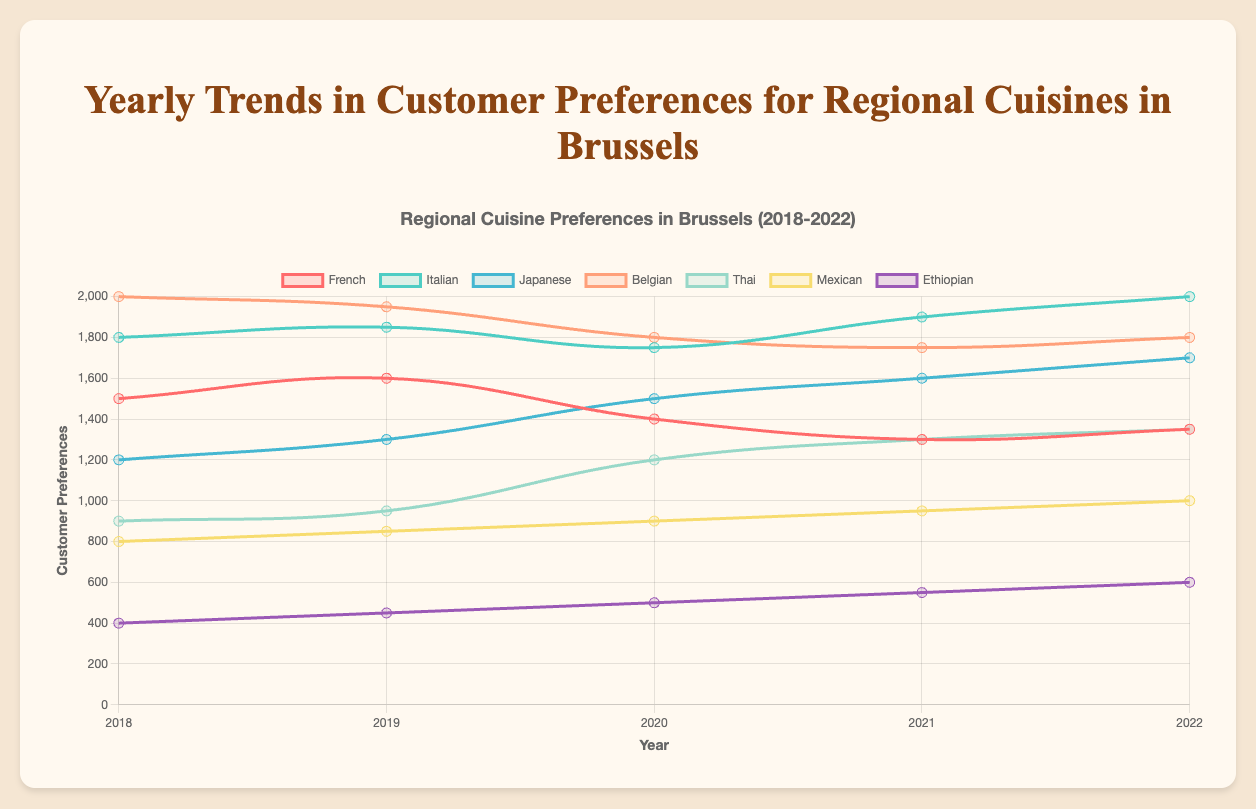Which cuisine had the highest customer preference in 2022? Look at the data for 2022, compare the values of each cuisine, and identify the highest one.
Answer: Italian How did the preference for Japanese cuisine change from 2020 to 2021? Compare the values for Japanese cuisine in 2020 (1500) and 2021 (1600). Calculate the difference: 1600 - 1500 = 100. The preference increased by 100.
Answer: Increased by 100 Which cuisine saw the largest increase in customer preference from 2018 to 2022? Calculate the difference in preference for each cuisine between 2018 and 2022, and then identify the cuisine with the largest positive difference. Italian (2000 - 1800 = 200), Japanese (1700 - 1200 = 500), Thai (1350 - 900 = 450), etc. Japanese saw the largest increase.
Answer: Japanese What is the average customer preference for Belgian cuisine over the years 2018 to 2022? Sum the values for Belgian cuisine over the five years: (2000 + 1950 + 1800 + 1750 + 1800) = 9300. Divide by the number of years (5): 9300 / 5 = 1860.
Answer: 1860 In which year did Thai cuisine's customer preference surpass that of French cuisine? Compare Thai and French preferences each year until Thai surpasses French. In 2020: French (1400), Thai (1200). In 2021: French (1300), Thai (1300). In 2022: French (1350), Thai (1350). Thai never surpasses French but equals it in 2021 and 2022.
Answer: Never surpassed, tied in 2021 and 2022 Which cuisines had a consistent increase in customer preference from 2018 to 2022? Check the yearly data to see which cuisines show an increasing trend every year. Ethiopian (400 -> 450 -> 500 -> 550 -> 600) is the only consistent increase.
Answer: Ethiopian What is the total increase in customer preference for Mexican cuisine from 2018 to 2022? Calculate the difference between 2022 and 2018 for Mexican cuisine: 1000 - 800 = 200.
Answer: 200 Which cuisine had the lowest preference in 2021, and what was the value? Identify the lowest value in 2021. Ethiopian (550) is the lowest.
Answer: Ethiopian, 550 How many cuisines had a decrease in customer preference from 2019 to 2020? Compare each cuisine's values from 2019 to 2020 and count those that decreased: French (1600 to 1400), Italian (1850 to 1750), Belgian (1950 to 1800). Total: 3.
Answer: 3 For which years did Belgian cuisine lead in customer preference? Compare Belgian cuisine's values against others each year. For 2018: Belgian (2000) is the highest.
Answer: 2018 